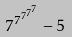Convert formula to latex. <formula><loc_0><loc_0><loc_500><loc_500>7 ^ { 7 ^ { 7 ^ { 7 ^ { 7 } } } } - 5</formula> 